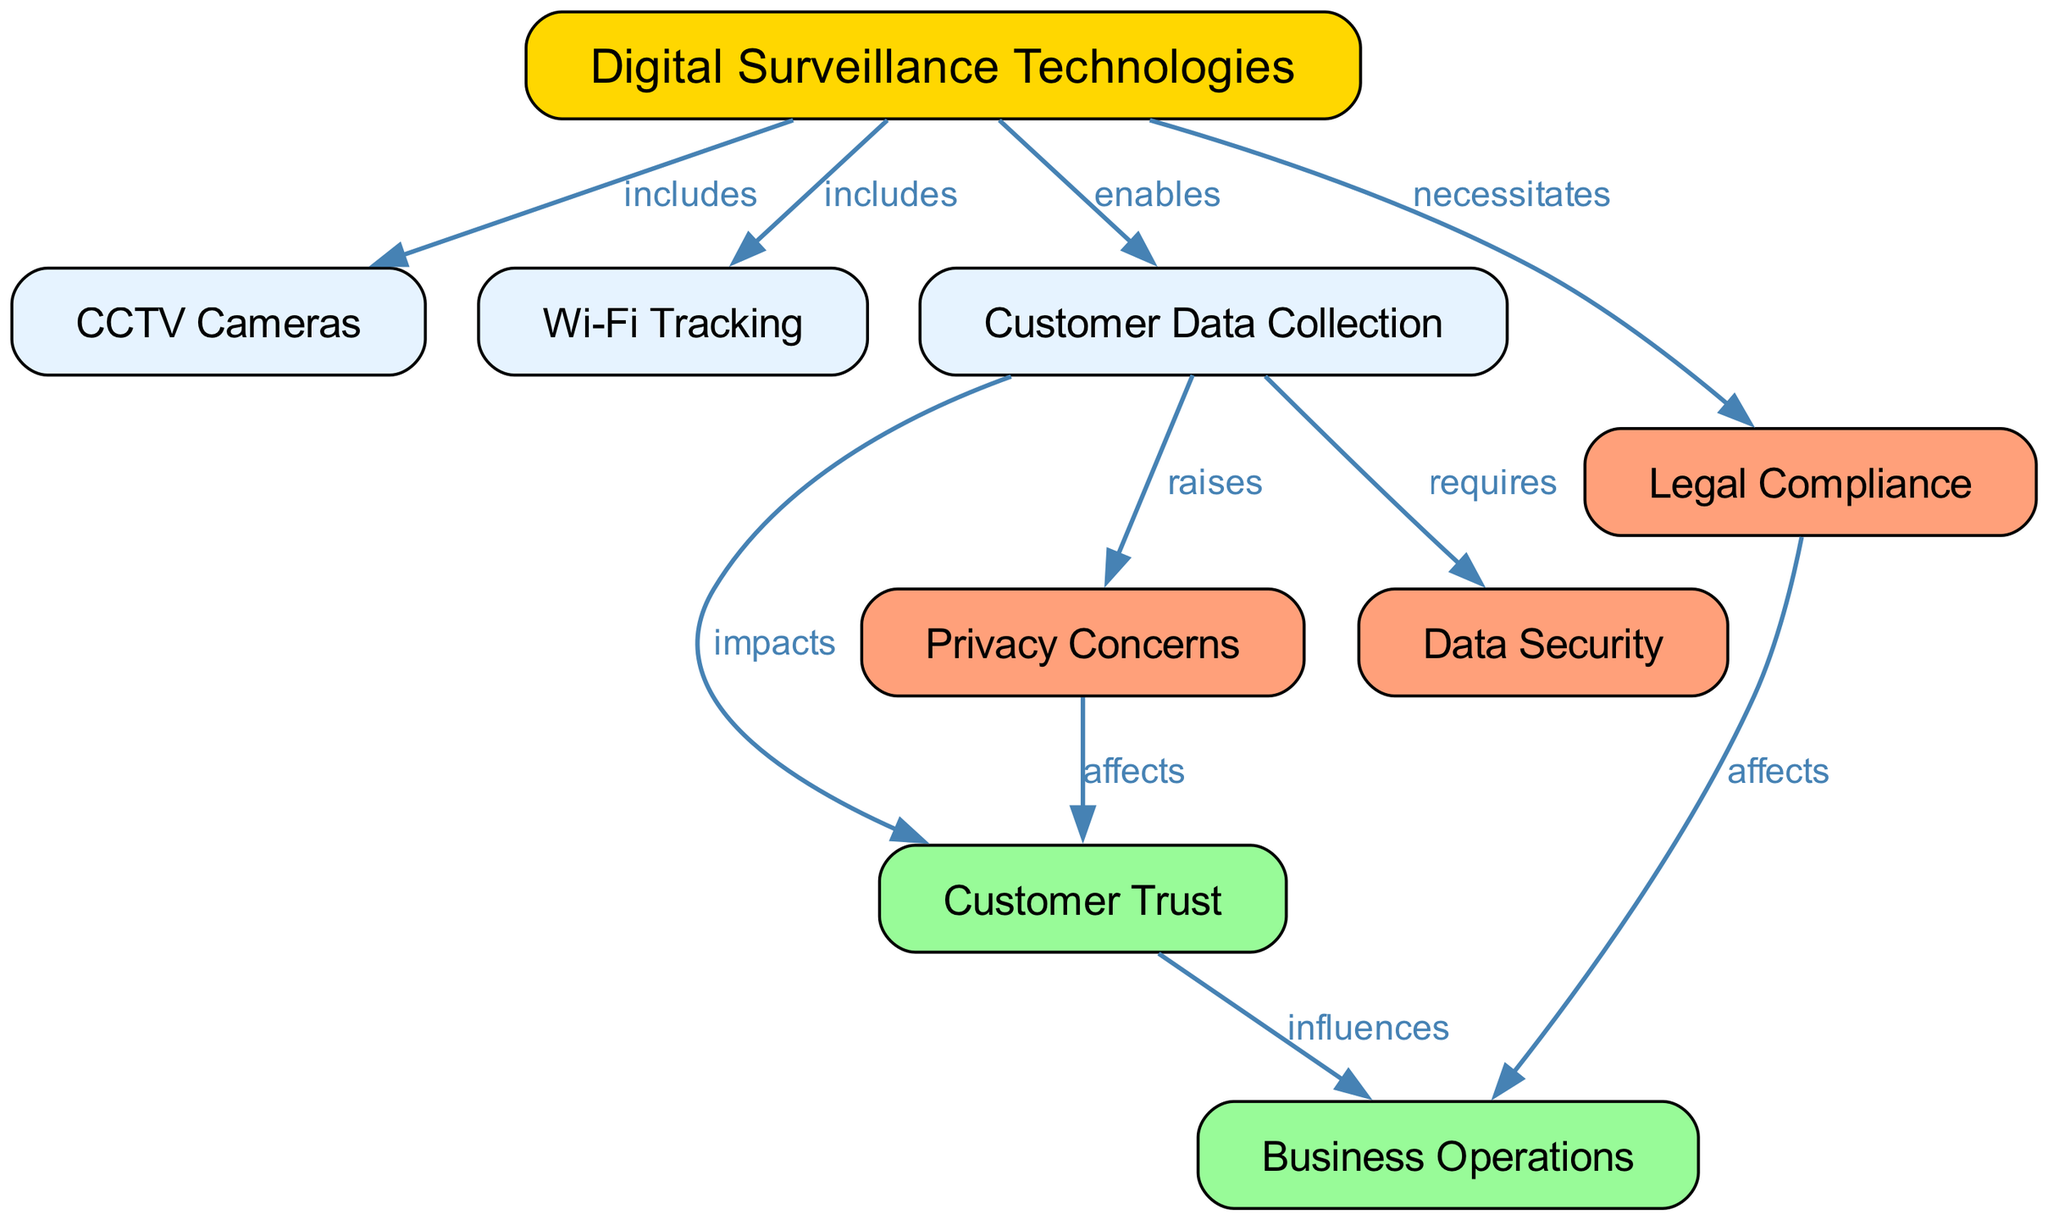What are the included types of digital surveillance technologies? The diagram lists CCTV Cameras and Wi-Fi Tracking as types of digital surveillance technologies that are included under the main category.
Answer: CCTV Cameras, Wi-Fi Tracking How does customer data collection impact customer trust? According to the diagram, customer data collection directly impacts customer trust, which is shown by the connection labeled "impacts" moving from customer data collection to customer trust.
Answer: Impacts What is a privacy concern that arises from customer data collection? The diagram indicates that customer data collection raises privacy concerns, linking this to customer data collection with the label "raises."
Answer: Raises How many edges are represented in the diagram? The diagram contains 10 edges connecting various nodes which illustrate relationships among different concepts, as counted in the edges section.
Answer: 10 How does privacy concern affect customer trust? The diagram shows a direct link labeled "affects" from privacy concerns to customer trust, indicating that privacy concerns have an impact on customer trust.
Answer: Affects Which node influences business operations? The diagram indicates that customer trust has an influence on business operations, marked by the edge labeled "influences."
Answer: Customer Trust What is required alongside customer data collection? The relationship in the diagram specifies that data security is necessary when collecting customer data, with the edge labeled "requires."
Answer: Data Security What necessitates legal compliance? The diagram shows that digital surveillance technologies necessitate legal compliance, illustrated by the edge connecting these two nodes with the label "necessitates."
Answer: Digital Surveillance Technologies What affects business operations? The diagram reveals two connecting influences on business operations: customer trust (influence) and legal compliance (affect). Thus, both impact business operations, but specifically, legal compliance affects.
Answer: Legal Compliance What do both customer trust and data collection connect to in terms of business operations? The diagram indicates that both customer trust and legal compliance influence business operations, highlighting how these factors are interconnected regarding the operational aspects of a business.
Answer: Customer Trust, Legal Compliance 